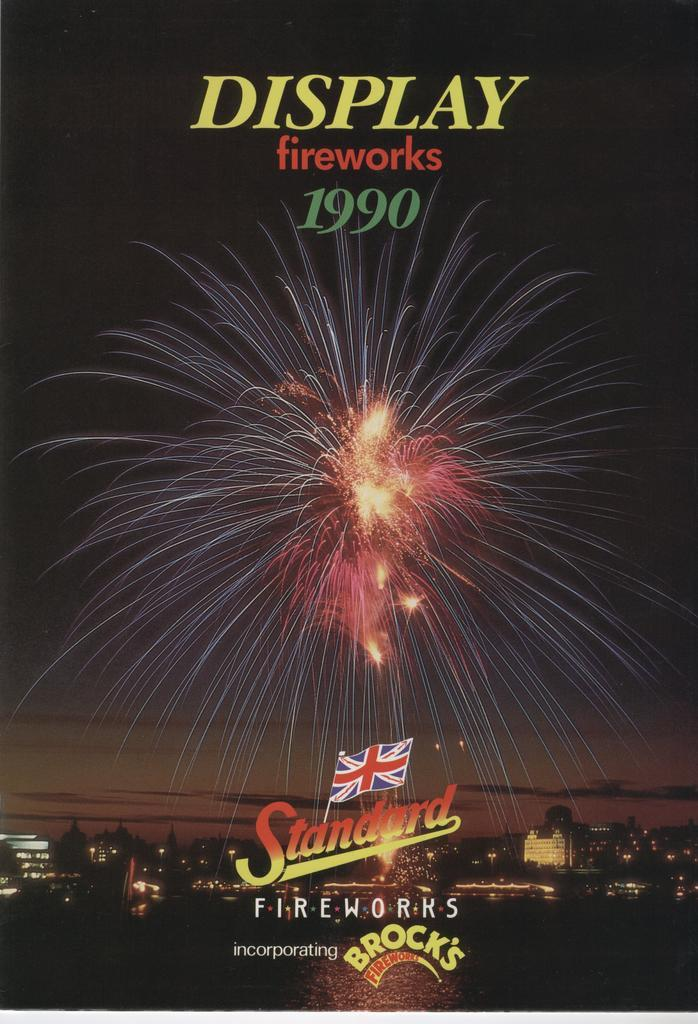<image>
Present a compact description of the photo's key features. A fireworks advertisement from Brock's fireworks in 1990. 